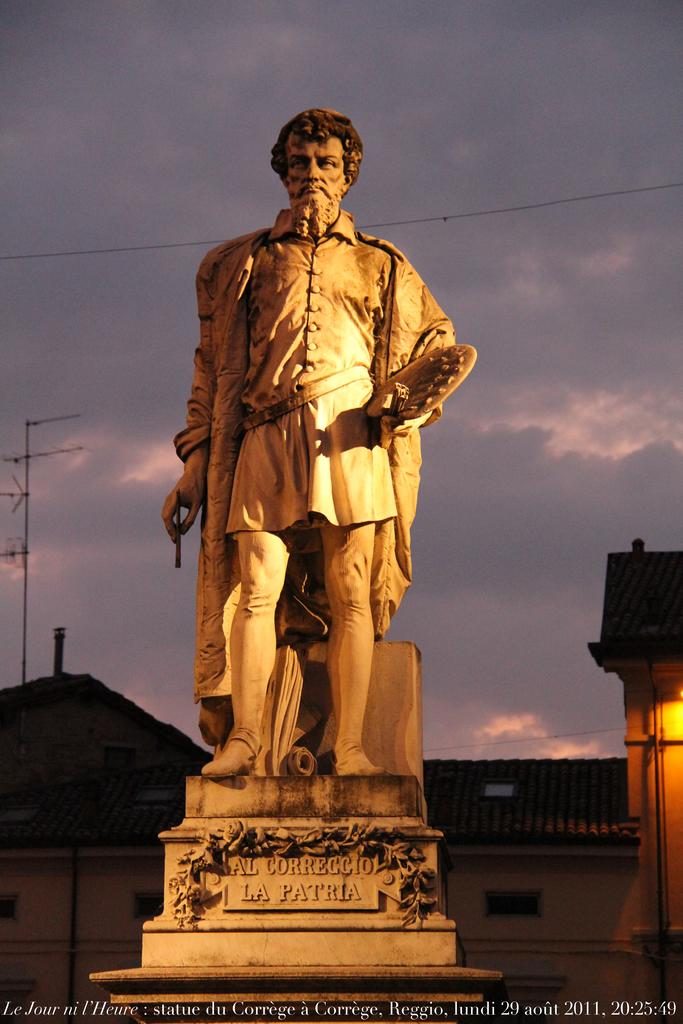What is the main subject of the image? There is a sculpture in the image. Is there any text associated with the sculpture? Yes, there is written text at the bottom of the image. What type of structures can be seen in the image? There are houses in the image. What else can be seen in the image besides the sculpture and houses? Cable wires are visible in the image. What is visible at the top of the image? The sky is visible at the top of the image, and clouds are present in the sky. What type of music can be heard playing in the background of the image? There is no music present in the image, as it is a still photograph. Was the sculpture affected by an earthquake in the image? There is no indication of an earthquake or any damage to the sculpture in the image. 